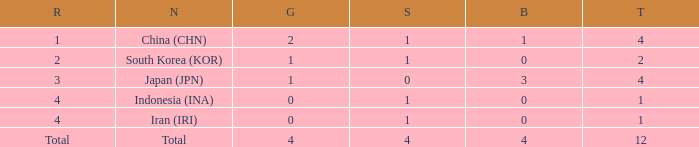What is the fewest gold medals for the nation with 4 silvers and more than 4 bronze? None. 